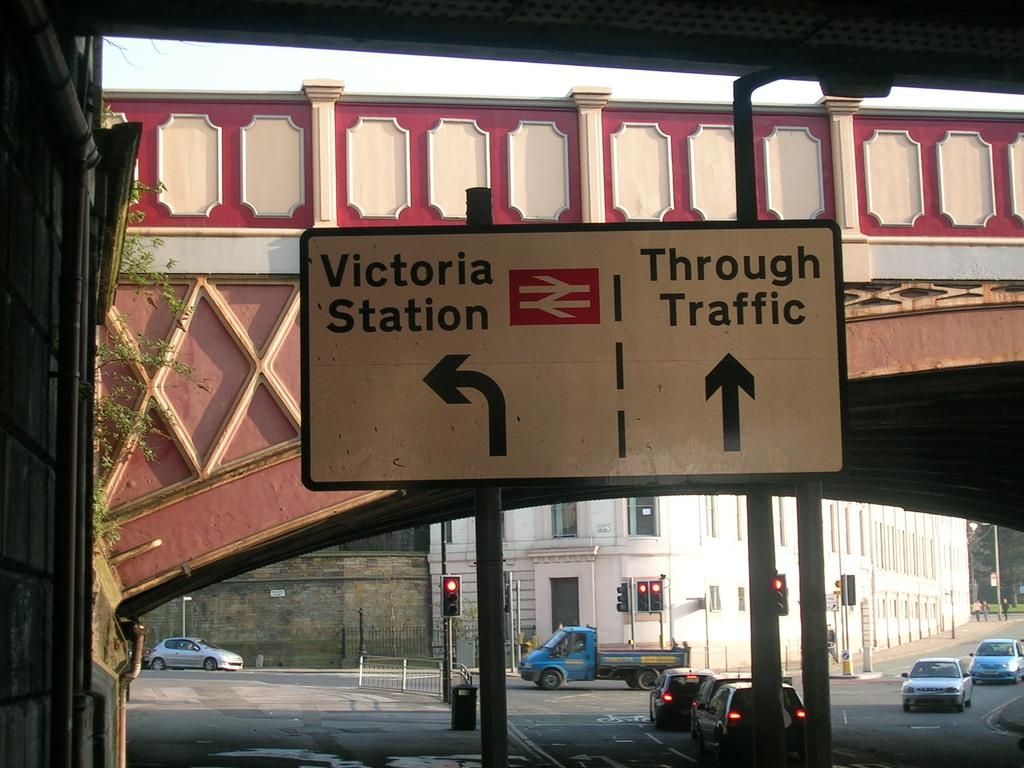Where would you go if you head left?
Offer a terse response. Victoria station. What is straight?
Make the answer very short. Through traffic. 